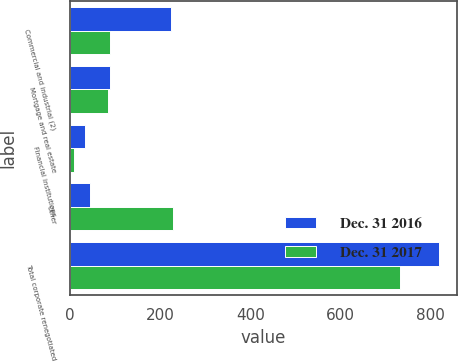<chart> <loc_0><loc_0><loc_500><loc_500><stacked_bar_chart><ecel><fcel>Commercial and industrial (2)<fcel>Mortgage and real estate<fcel>Financial institutions<fcel>Other<fcel>Total corporate renegotiated<nl><fcel>Dec. 31 2016<fcel>225<fcel>90<fcel>33<fcel>45<fcel>818<nl><fcel>Dec. 31 2017<fcel>89<fcel>84<fcel>9<fcel>228<fcel>732<nl></chart> 